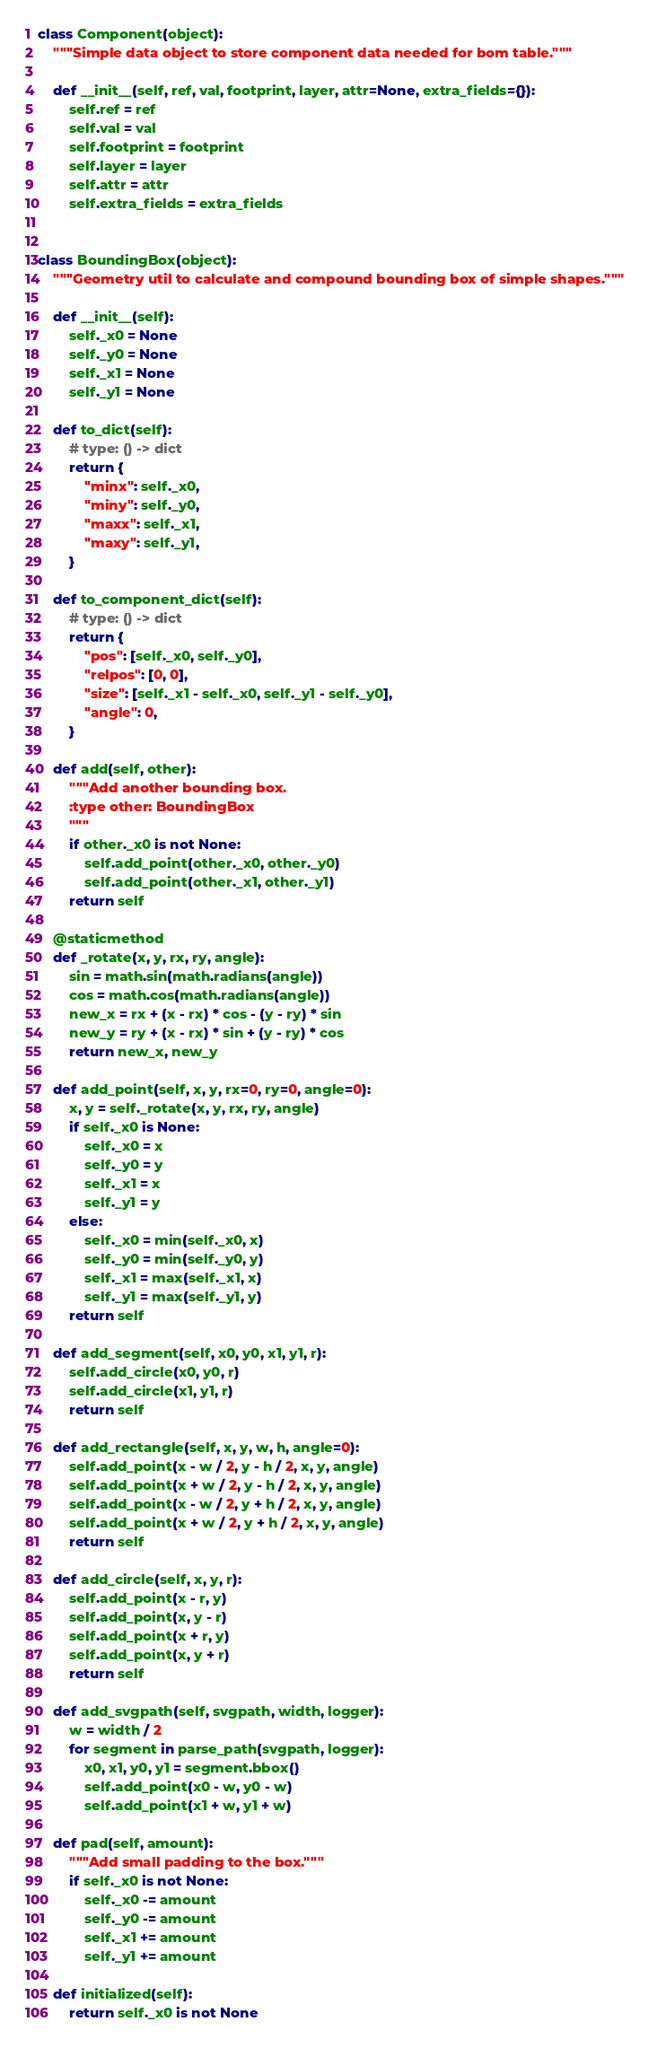<code> <loc_0><loc_0><loc_500><loc_500><_Python_>

class Component(object):
    """Simple data object to store component data needed for bom table."""

    def __init__(self, ref, val, footprint, layer, attr=None, extra_fields={}):
        self.ref = ref
        self.val = val
        self.footprint = footprint
        self.layer = layer
        self.attr = attr
        self.extra_fields = extra_fields


class BoundingBox(object):
    """Geometry util to calculate and compound bounding box of simple shapes."""

    def __init__(self):
        self._x0 = None
        self._y0 = None
        self._x1 = None
        self._y1 = None

    def to_dict(self):
        # type: () -> dict
        return {
            "minx": self._x0,
            "miny": self._y0,
            "maxx": self._x1,
            "maxy": self._y1,
        }

    def to_component_dict(self):
        # type: () -> dict
        return {
            "pos": [self._x0, self._y0],
            "relpos": [0, 0],
            "size": [self._x1 - self._x0, self._y1 - self._y0],
            "angle": 0,
        }

    def add(self, other):
        """Add another bounding box.
        :type other: BoundingBox
        """
        if other._x0 is not None:
            self.add_point(other._x0, other._y0)
            self.add_point(other._x1, other._y1)
        return self

    @staticmethod
    def _rotate(x, y, rx, ry, angle):
        sin = math.sin(math.radians(angle))
        cos = math.cos(math.radians(angle))
        new_x = rx + (x - rx) * cos - (y - ry) * sin
        new_y = ry + (x - rx) * sin + (y - ry) * cos
        return new_x, new_y

    def add_point(self, x, y, rx=0, ry=0, angle=0):
        x, y = self._rotate(x, y, rx, ry, angle)
        if self._x0 is None:
            self._x0 = x
            self._y0 = y
            self._x1 = x
            self._y1 = y
        else:
            self._x0 = min(self._x0, x)
            self._y0 = min(self._y0, y)
            self._x1 = max(self._x1, x)
            self._y1 = max(self._y1, y)
        return self

    def add_segment(self, x0, y0, x1, y1, r):
        self.add_circle(x0, y0, r)
        self.add_circle(x1, y1, r)
        return self

    def add_rectangle(self, x, y, w, h, angle=0):
        self.add_point(x - w / 2, y - h / 2, x, y, angle)
        self.add_point(x + w / 2, y - h / 2, x, y, angle)
        self.add_point(x - w / 2, y + h / 2, x, y, angle)
        self.add_point(x + w / 2, y + h / 2, x, y, angle)
        return self

    def add_circle(self, x, y, r):
        self.add_point(x - r, y)
        self.add_point(x, y - r)
        self.add_point(x + r, y)
        self.add_point(x, y + r)
        return self

    def add_svgpath(self, svgpath, width, logger):
        w = width / 2
        for segment in parse_path(svgpath, logger):
            x0, x1, y0, y1 = segment.bbox()
            self.add_point(x0 - w, y0 - w)
            self.add_point(x1 + w, y1 + w)

    def pad(self, amount):
        """Add small padding to the box."""
        if self._x0 is not None:
            self._x0 -= amount
            self._y0 -= amount
            self._x1 += amount
            self._y1 += amount

    def initialized(self):
        return self._x0 is not None
</code> 